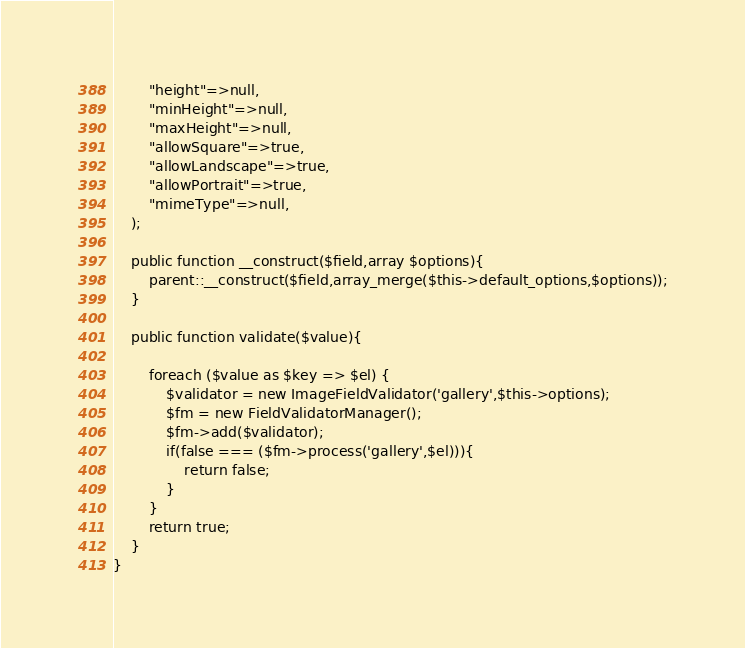Convert code to text. <code><loc_0><loc_0><loc_500><loc_500><_PHP_>		"height"=>null,
		"minHeight"=>null,
		"maxHeight"=>null,
		"allowSquare"=>true,
		"allowLandscape"=>true,
		"allowPortrait"=>true,
		"mimeType"=>null,
	);

	public function __construct($field,array $options){
		parent::__construct($field,array_merge($this->default_options,$options));
	}

	public function validate($value){

		foreach ($value as $key => $el) {
			$validator = new ImageFieldValidator('gallery',$this->options);
			$fm = new FieldValidatorManager();
			$fm->add($validator);
			if(false === ($fm->process('gallery',$el))){
				return false;
			}
		}
		return true;
	}
}</code> 